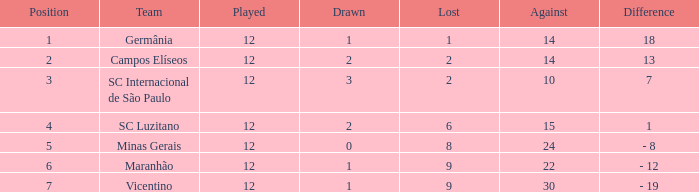What is the sum of drawn that has a played more than 12? 0.0. 